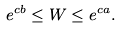<formula> <loc_0><loc_0><loc_500><loc_500>e ^ { c b } \leq W \leq e ^ { c a } .</formula> 